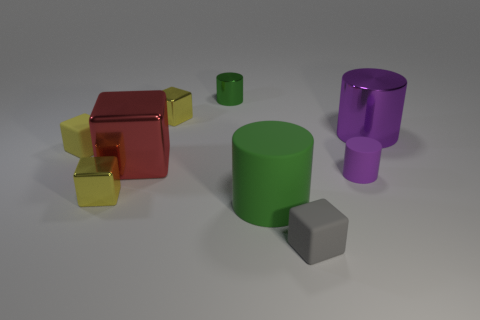How many small things are both in front of the green matte cylinder and right of the small gray matte block? In the image, we see various objects, but based on the relative positions of the green matte cylinder and the small gray matte block, there are no small things that are both directly in front of the green cylinder and to the right of the gray block. The closest item that might fit this description is a small green cylinder, but it's actually to the left of the gray block when facing the green cylinder. 